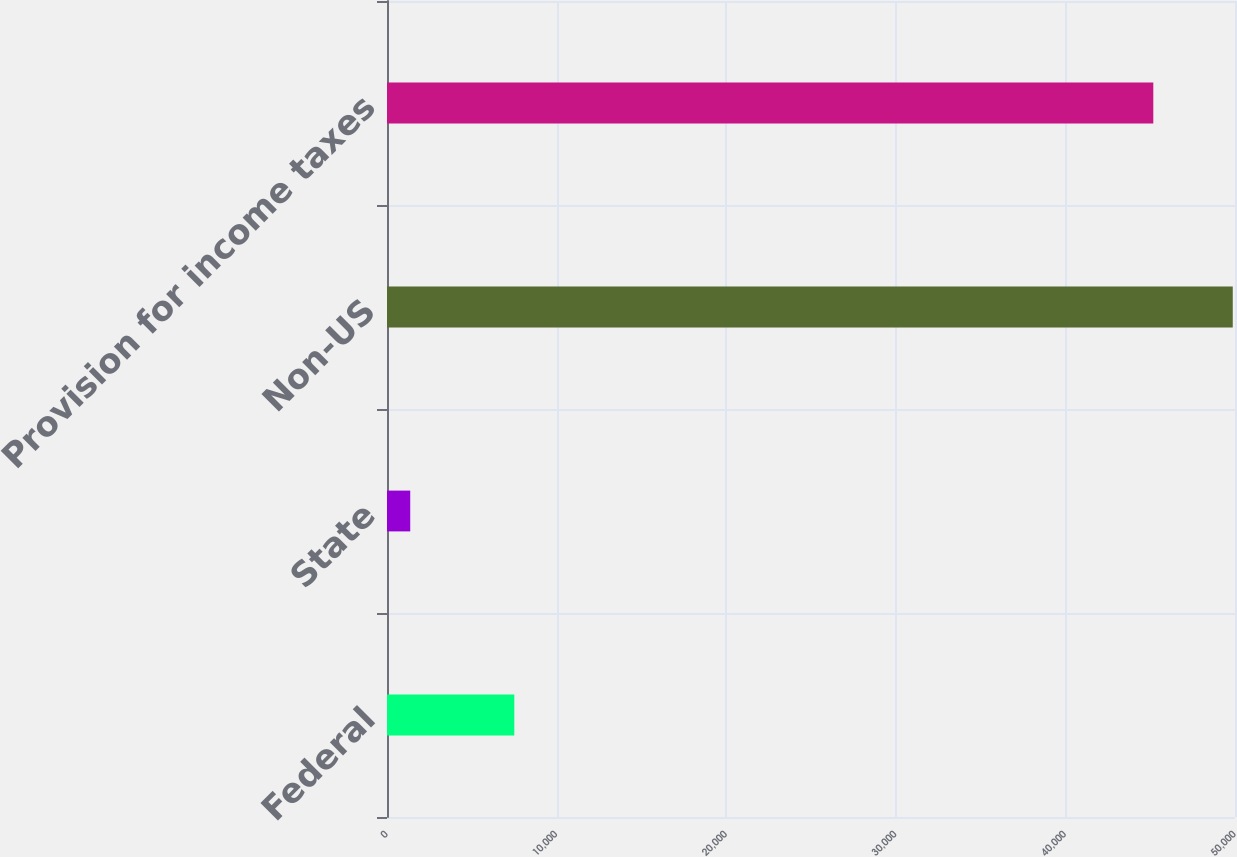Convert chart. <chart><loc_0><loc_0><loc_500><loc_500><bar_chart><fcel>Federal<fcel>State<fcel>Non-US<fcel>Provision for income taxes<nl><fcel>7507<fcel>1370<fcel>49868.1<fcel>45183<nl></chart> 